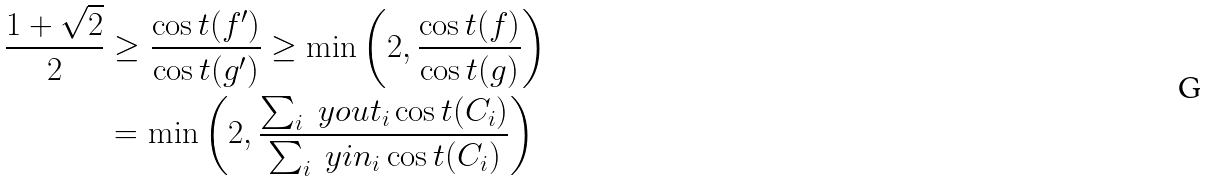Convert formula to latex. <formula><loc_0><loc_0><loc_500><loc_500>\frac { 1 + \sqrt { 2 } } { 2 } & \geq \frac { \cos t ( f ^ { \prime } ) } { \cos t ( g ^ { \prime } ) } \geq \min \left ( 2 , \frac { \cos t ( f ) } { \cos t ( g ) } \right ) \\ & = \min \left ( 2 , \frac { \sum _ { i } \ y o u t _ { i } \cos t ( C _ { i } ) } { \sum _ { i } \ y i n _ { i } \cos t ( C _ { i } ) } \right )</formula> 